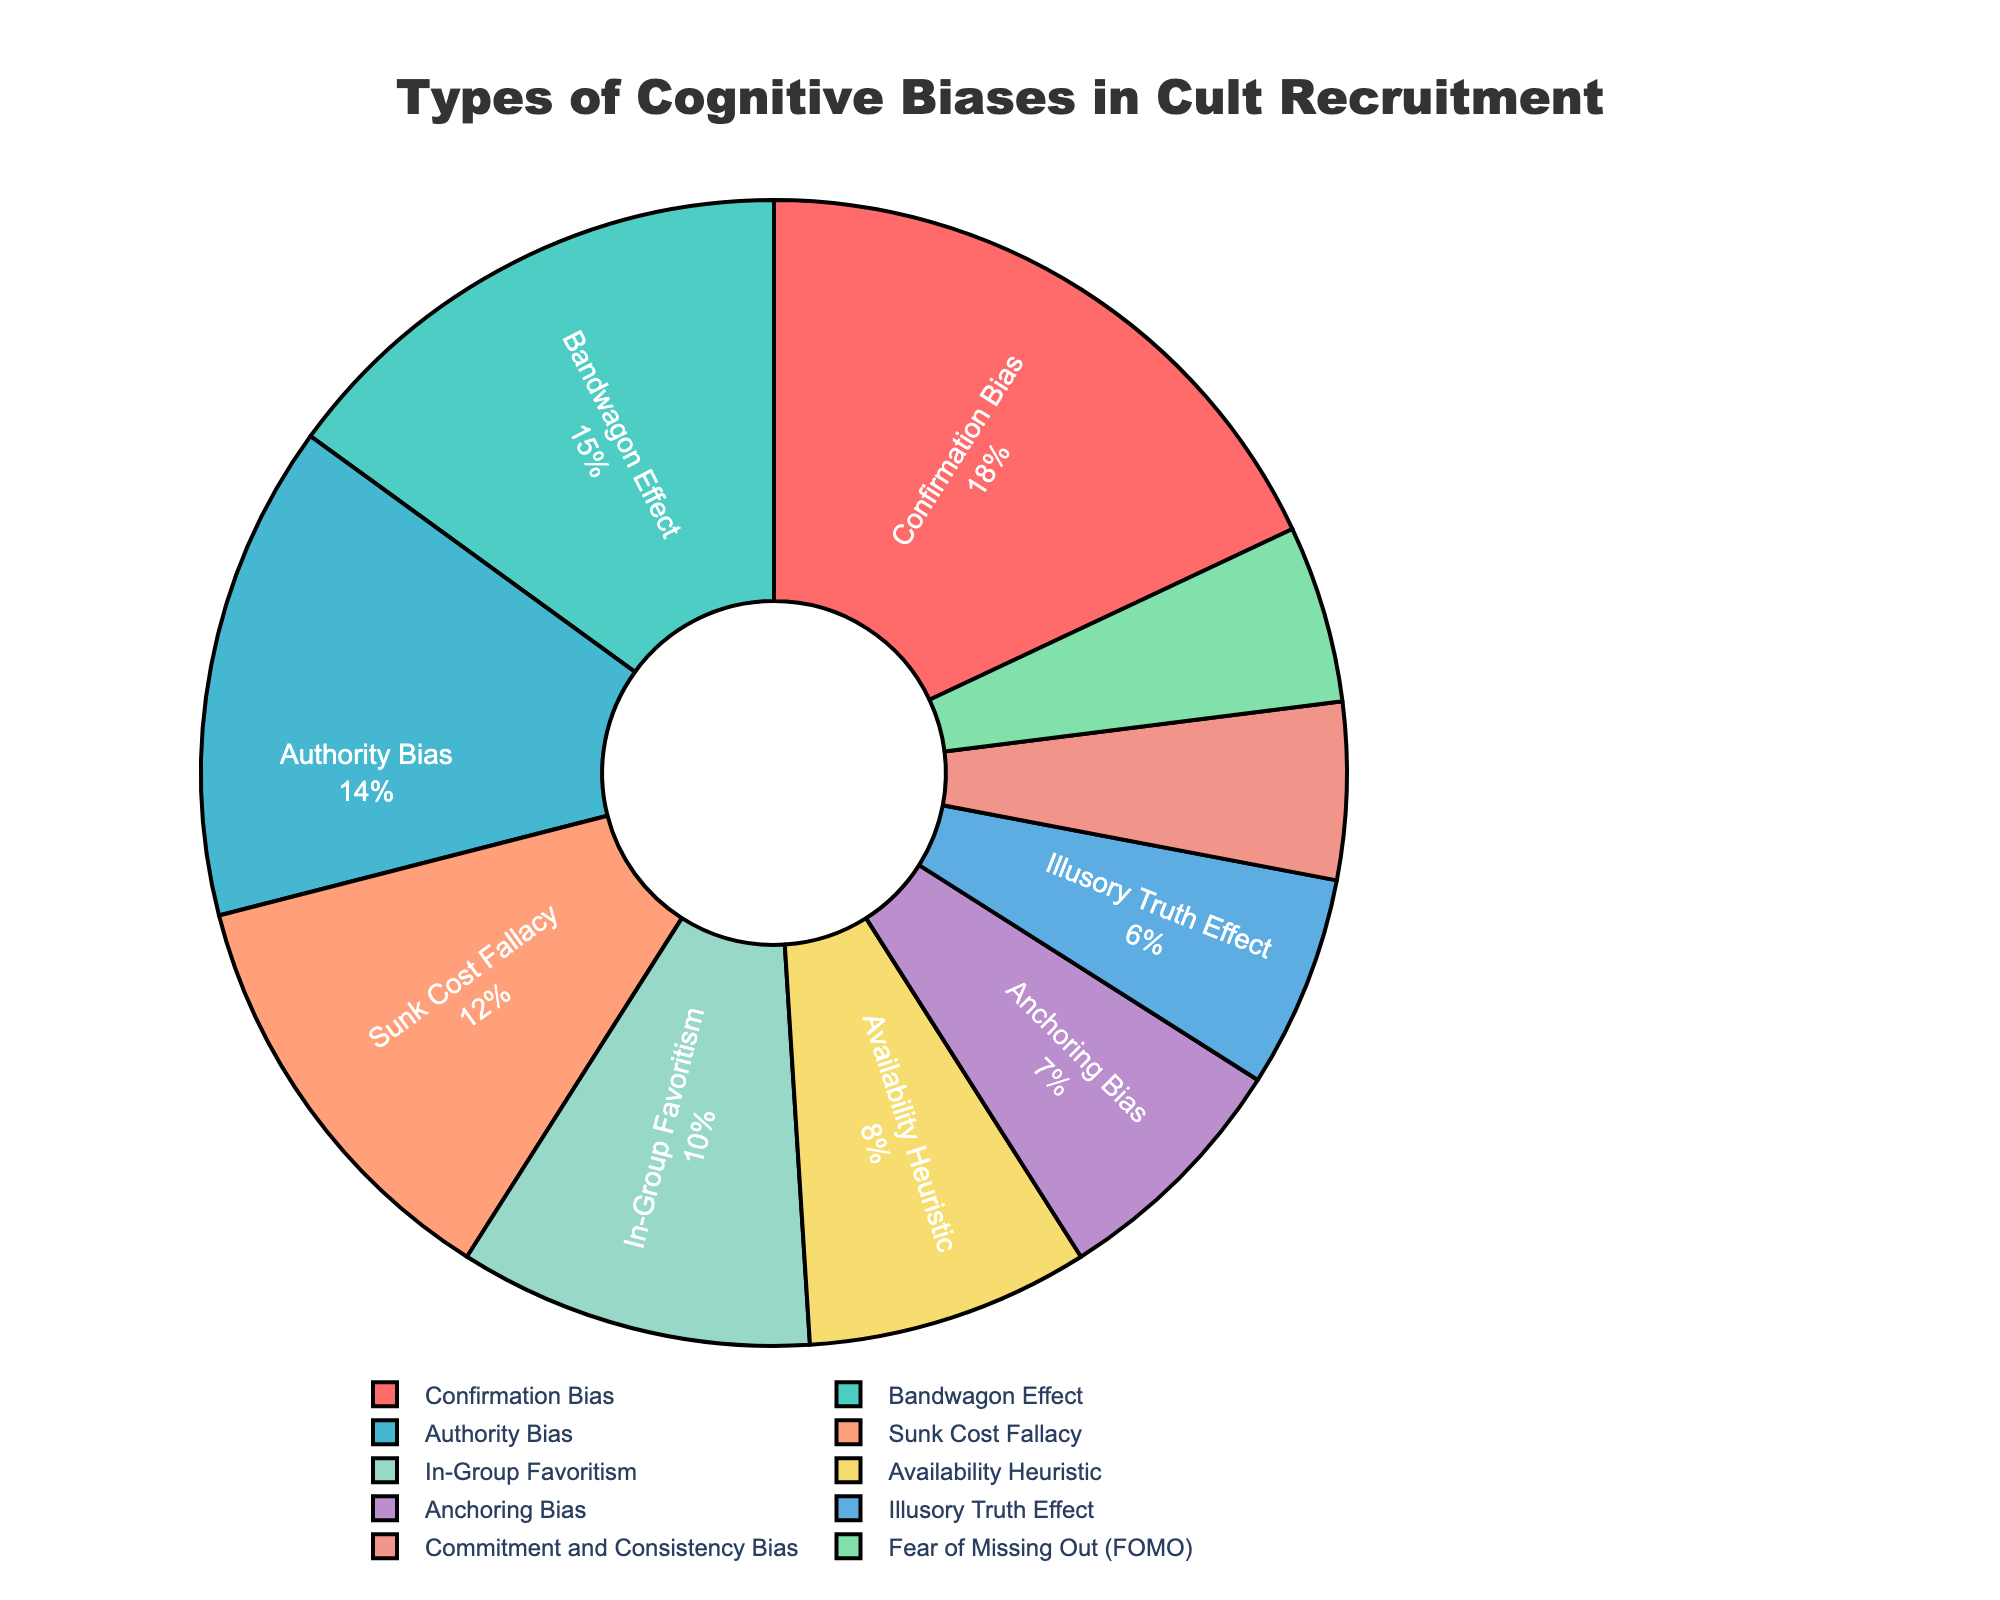what is the percentage of confirmation bias used in cult recruitment? The slice representing the Confirmation Bias shows 18%.
Answer: 18% which cognitive bias has the smallest percentage in the pie chart? The slice with the smallest size is labeled "Fear of Missing Out (FOMO)" with 5%.
Answer: Fear of Missing Out (FOMO) which bias has a higher percentage: Authority Bias or Availability Heuristic? Authority Bias has a percentage of 14%, and Availability Heuristic has 8%, so Authority Bias is higher.
Answer: Authority Bias how does the percentage of Bandwagon Effect compare to that of Sunk Cost Fallacy? Bandwagon Effect is at 15%, while Sunk Cost Fallacy is at 12%. Therefore, Bandwagon Effect is higher by 3%.
Answer: Bandwagon Effect is higher what's the combined percentage of In-Group Favoritism and Illusory Truth Effect? In-Group Favoritism is 10% and Illusory Truth Effect is 6%. Summing them up gives 10% + 6% = 16%.
Answer: 16% how many biases have a percentage greater than or equal to 10%? By inspecting the pie chart, the biases with percentages greater than or equal to 10% are Confirmation Bias (18%), Bandwagon Effect (15%), Authority Bias (14%), and In-Group Favoritism (10%). There are 4 such biases.
Answer: 4 biases is the percentage of Commitment and Consistency Bias equal to that of Fear of Missing Out (FOMO)? Both Commitment and Consistency Bias and Fear of Missing Out (FOMO) slices show 5%.
Answer: Yes what is the difference in percentage between Anchoring Bias and Availability Heuristic? Anchoring Bias is at 7%, and Availability Heuristic is at 8%. The difference is 8% - 7% = 1%.
Answer: 1% what color represents the Bandwagon Effect in the pie chart? The Bandwagon Effect slice is colored in green.
Answer: Green 